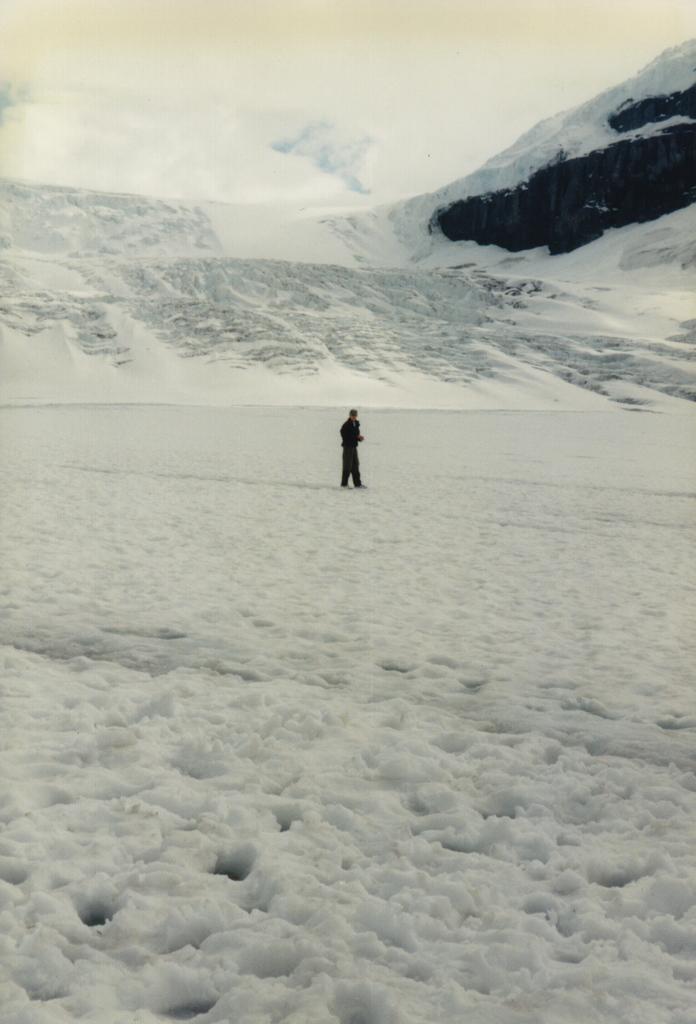In one or two sentences, can you explain what this image depicts? This image is taken outdoors. At the top of the image there is the sky with clouds. At the bottom of the image there is snow on the ground. In the background there are a few hills covered with snow. In the middle of the image a person is standing on the ground. 